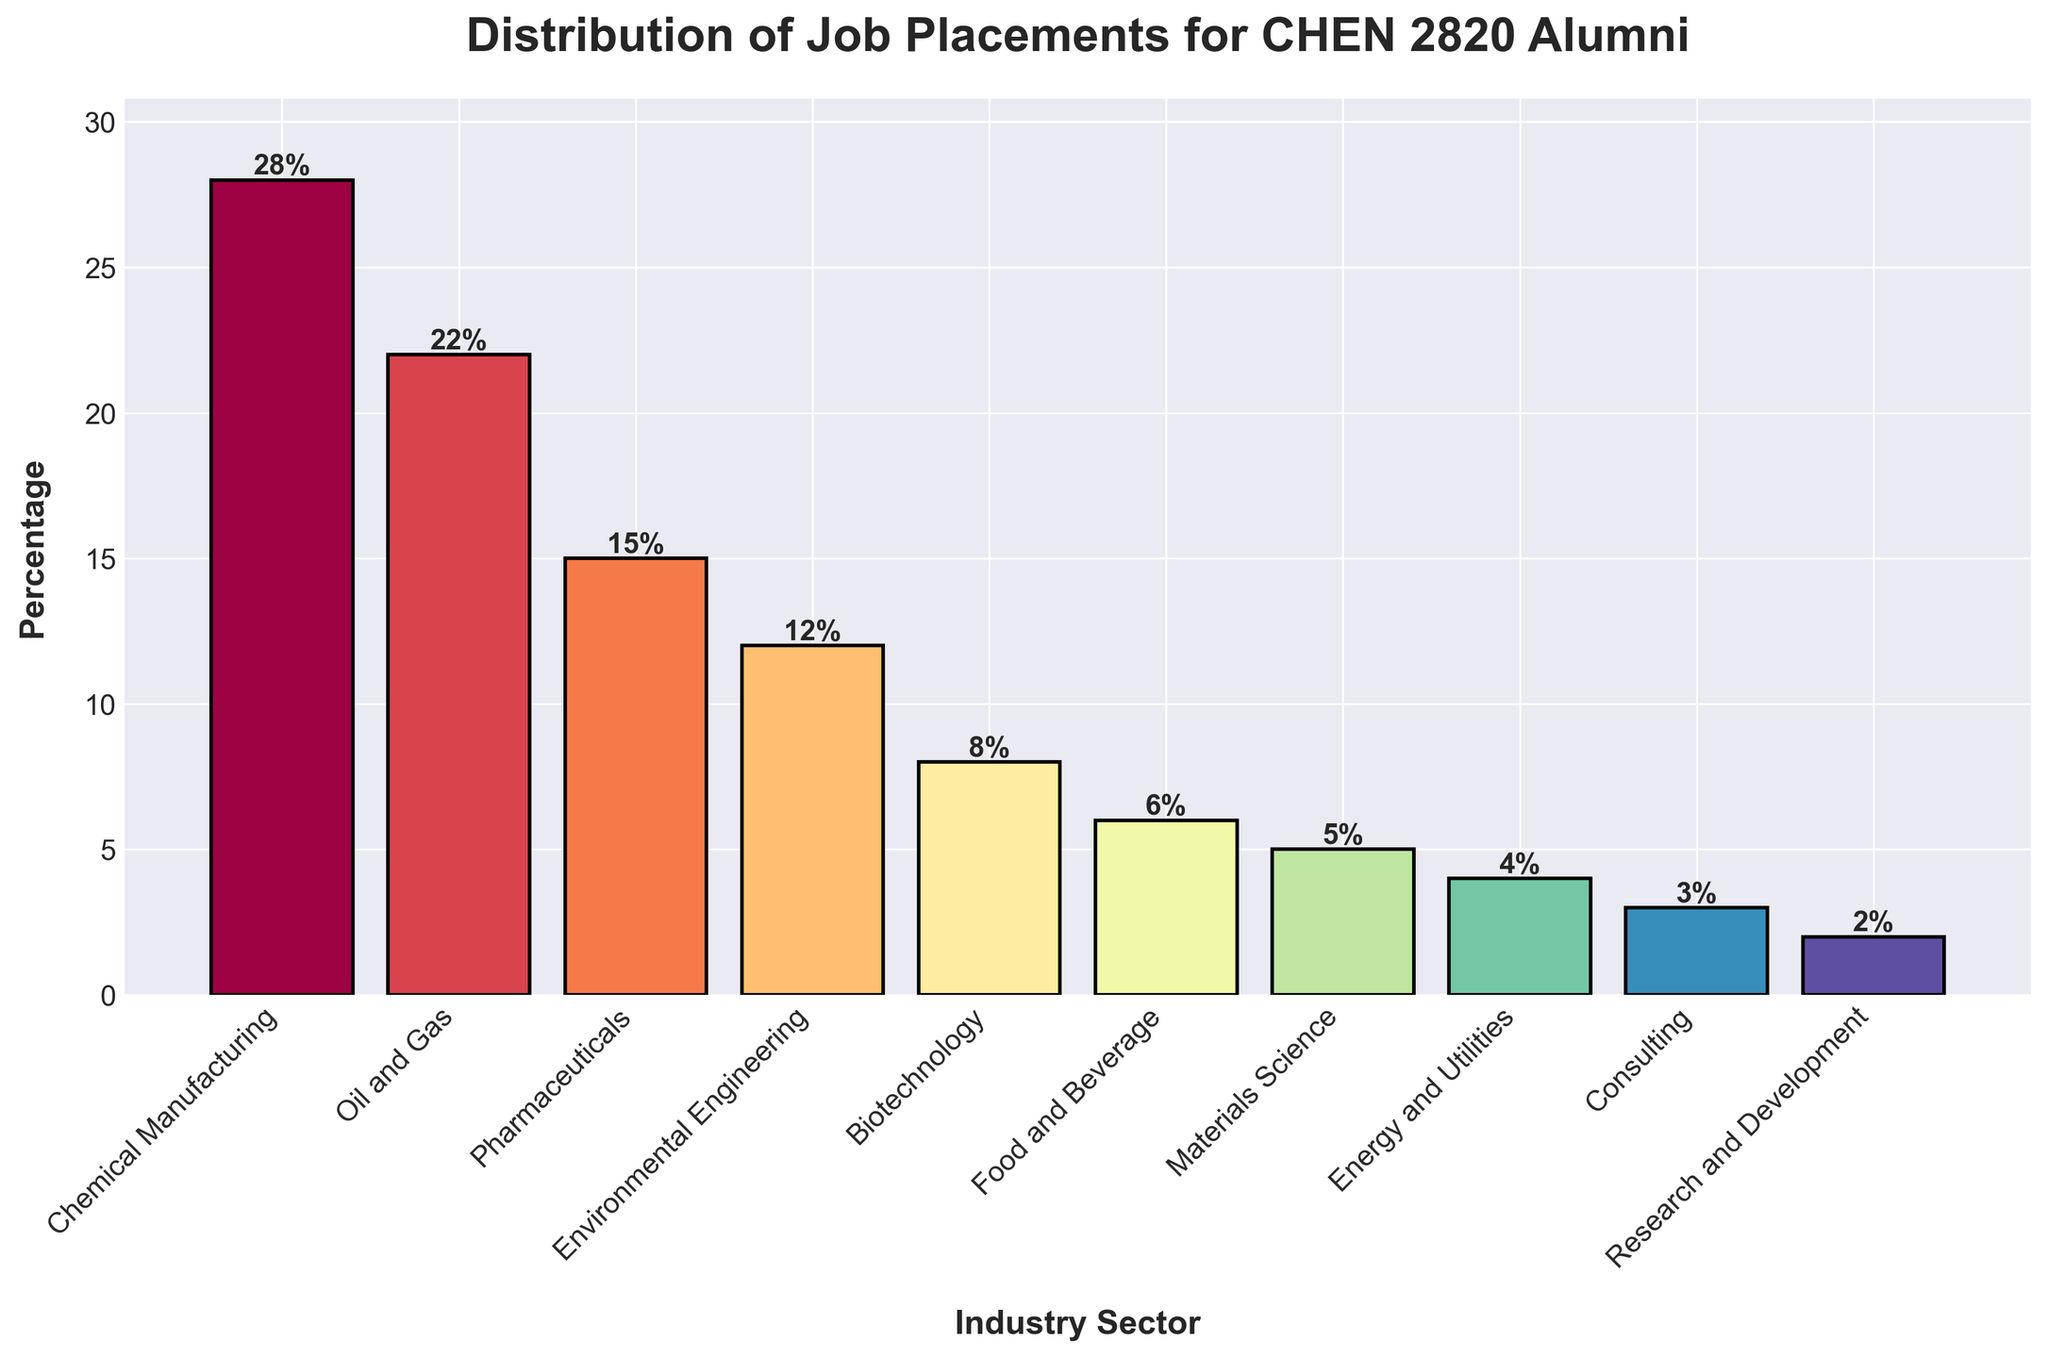What is the industry sector with the highest percentage of job placements? The tallest bar corresponds to Chemical Manufacturing, which has the highest percentage at 28%.
Answer: Chemical Manufacturing What is the difference in job placement percentage between Oil and Gas and Biotechnology? The job placement percentage for Oil and Gas is 22%, and for Biotechnology, it's 8%. The difference is 22% - 8% = 14%.
Answer: 14% What is the combined job placement percentage for the top three industry sectors? The top three industry sectors are Chemical Manufacturing (28%), Oil and Gas (22%), and Pharmaceuticals (15%). The combined percentage is 28% + 22% + 15% = 65%.
Answer: 65% Which industry sector has a lower job placement percentage: Food and Beverage or Consulting? The heights of the bars show that Food and Beverage has 6%, while Consulting has 3%. Thus, Consulting has a lower job placement percentage.
Answer: Consulting What is the average job placement percentage for all industry sectors? Summing the percentages of all industry sectors: 28 + 22 + 15 + 12 + 8 + 6 + 5 + 4 + 3 + 2 = 105. Then, dividing by the number of sectors, 105 / 10 = 10.5%.
Answer: 10.5% Which industry sectors have a job placement percentage lower than 10%? The bar heights for sectors lower than 10% are Biotechnology (8%), Food and Beverage (6%), Materials Science (5%), Energy and Utilities (4%), Consulting (3%), and Research and Development (2%).
Answer: Biotechnology, Food and Beverage, Materials Science, Energy and Utilities, Consulting, Research and Development How much taller is the bar for Chemical Manufacturing compared to Energy and Utilities? The height for Chemical Manufacturing is 28%, and for Energy and Utilities, it is 4%. The difference in bar height is 28% - 4% = 24%.
Answer: 24% Are there any industry sectors with a job placement percentage exactly equal to 12%? By examining the height of the bars, we see that Environmental Engineering has a percentage exactly equal to 12%.
Answer: Environmental Engineering 